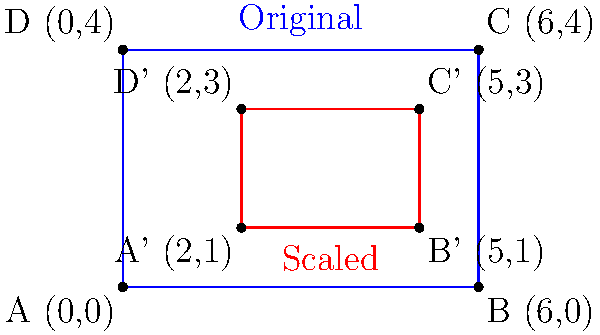A billboard advertisement originally designed for a 6x4 meter space needs to be scaled down to fit a 3x2 meter space while maintaining its aspect ratio. Given that the bottom-left corner of the new billboard is positioned at (2,1), what are the coordinates of the top-right corner of the scaled billboard? To solve this problem, we need to follow these steps:

1) First, let's determine the scale factor:
   Original dimensions: 6x4 meters
   New dimensions: 3x2 meters
   Scale factor = 3/6 = 2/4 = 1/2 (or 0.5)

2) The original billboard's bottom-left corner is at (0,0) and its top-right corner is at (6,4).

3) The new billboard's bottom-left corner is given as (2,1).

4) To find the top-right corner, we need to:
   a) Scale the original dimensions by 0.5
   b) Add these scaled dimensions to the new bottom-left corner coordinates

5) Scaling the original dimensions:
   Width: $6 * 0.5 = 3$
   Height: $4 * 0.5 = 2$

6) Adding to the new bottom-left corner:
   x-coordinate: $2 + 3 = 5$
   y-coordinate: $1 + 2 = 3$

Therefore, the coordinates of the top-right corner of the scaled billboard are (5,3).
Answer: (5,3) 